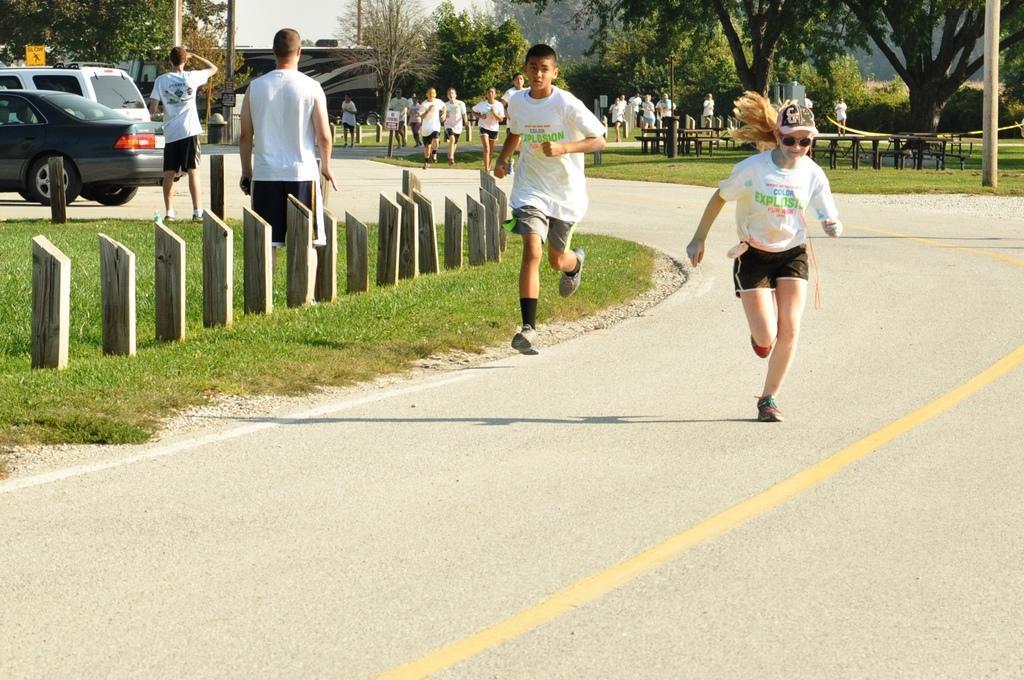Can you describe this image briefly? In this image I can see people among them some are standing and some are running on the road. These people are wearing white color T-shirts. Here I can see wooden objects, the grass, poles, vehicles on the road, buildings and trees. Here I can see the sky. 